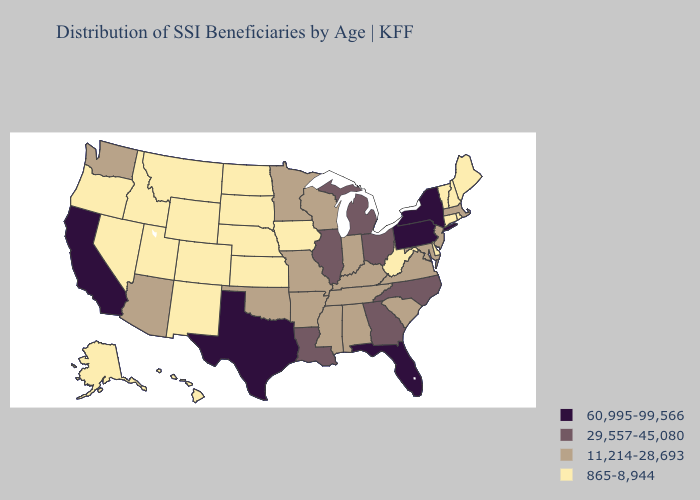Does Alabama have a higher value than South Carolina?
Quick response, please. No. Among the states that border Indiana , which have the highest value?
Concise answer only. Illinois, Michigan, Ohio. Does Oklahoma have the lowest value in the USA?
Quick response, please. No. What is the value of New Jersey?
Be succinct. 11,214-28,693. Which states have the lowest value in the USA?
Give a very brief answer. Alaska, Colorado, Connecticut, Delaware, Hawaii, Idaho, Iowa, Kansas, Maine, Montana, Nebraska, Nevada, New Hampshire, New Mexico, North Dakota, Oregon, Rhode Island, South Dakota, Utah, Vermont, West Virginia, Wyoming. Is the legend a continuous bar?
Write a very short answer. No. What is the value of Iowa?
Keep it brief. 865-8,944. What is the highest value in states that border Utah?
Short answer required. 11,214-28,693. What is the value of Nebraska?
Short answer required. 865-8,944. What is the value of North Carolina?
Concise answer only. 29,557-45,080. Does the first symbol in the legend represent the smallest category?
Concise answer only. No. Name the states that have a value in the range 11,214-28,693?
Give a very brief answer. Alabama, Arizona, Arkansas, Indiana, Kentucky, Maryland, Massachusetts, Minnesota, Mississippi, Missouri, New Jersey, Oklahoma, South Carolina, Tennessee, Virginia, Washington, Wisconsin. What is the highest value in the South ?
Write a very short answer. 60,995-99,566. Which states have the highest value in the USA?
Short answer required. California, Florida, New York, Pennsylvania, Texas. Does the first symbol in the legend represent the smallest category?
Quick response, please. No. 